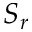Convert formula to latex. <formula><loc_0><loc_0><loc_500><loc_500>S _ { r }</formula> 